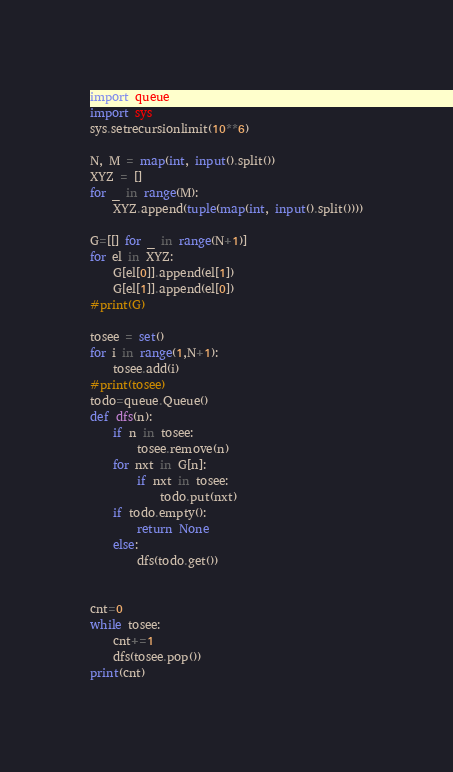Convert code to text. <code><loc_0><loc_0><loc_500><loc_500><_Python_>import queue
import sys
sys.setrecursionlimit(10**6)

N, M = map(int, input().split())
XYZ = []
for _ in range(M):
    XYZ.append(tuple(map(int, input().split())))

G=[[] for _ in range(N+1)]
for el in XYZ:
    G[el[0]].append(el[1])
    G[el[1]].append(el[0])
#print(G)

tosee = set()
for i in range(1,N+1):
    tosee.add(i)
#print(tosee)
todo=queue.Queue()
def dfs(n):
    if n in tosee:
        tosee.remove(n)
    for nxt in G[n]:
        if nxt in tosee:
            todo.put(nxt)
    if todo.empty():
        return None
    else:
        dfs(todo.get())


cnt=0
while tosee:
    cnt+=1
    dfs(tosee.pop())
print(cnt)
</code> 